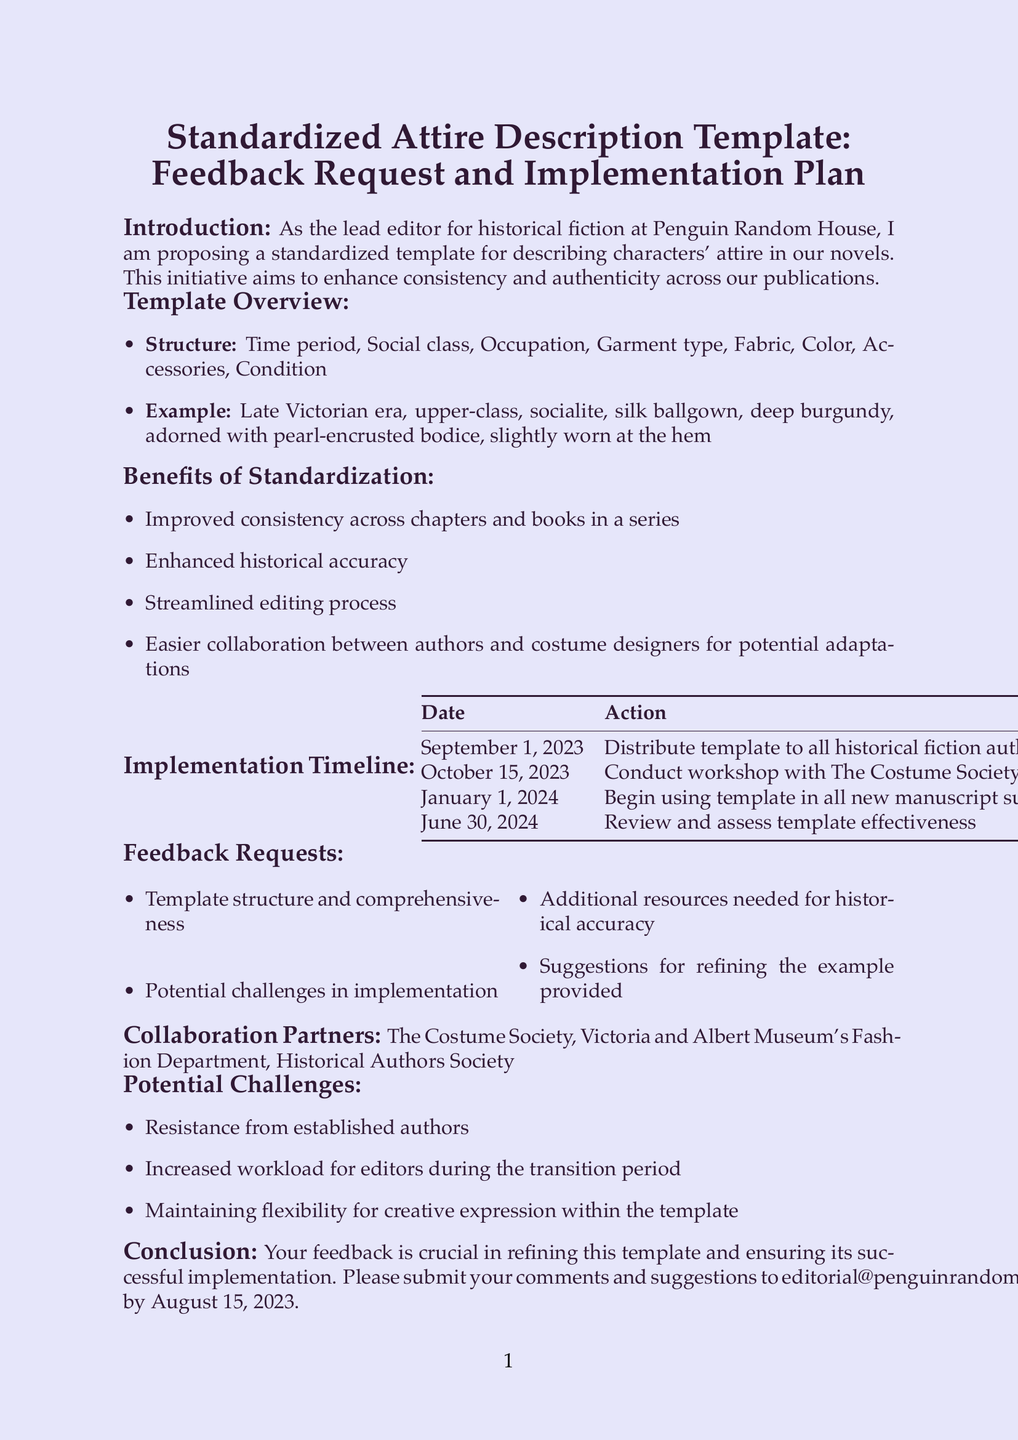what is the title of the memo? The title of the memo is explicitly stated at the top of the document as "Standardized Attire Description Template: Feedback Request and Implementation Plan."
Answer: Standardized Attire Description Template: Feedback Request and Implementation Plan who is proposing the standardized template? The memo states that the lead editor for historical fiction at Penguin Random House is proposing the standardized template.
Answer: lead editor for historical fiction what is the deadline for submitting feedback? The document specifies that feedback should be submitted by August 15, 2023.
Answer: August 15, 2023 how many phases are in the implementation timeline? The implementation timeline consists of four distinct phases as outlined in the document.
Answer: four what is the example provided for the template? An example of the attire description template is provided in the memo to illustrate its usage.
Answer: Late Victorian era, upper-class, socialite, silk ballgown, deep burgundy, adorned with pearl-encrusted bodice, slightly worn at the hem name one collaboration partner mentioned in the document. The memo lists collaboration partners, and one example is The Costume Society.
Answer: The Costume Society what is one potential challenge mentioned in the document? The document highlights several potential challenges, including "Resistance from established authors."
Answer: Resistance from established authors when will the template start being used in new manuscript submissions? The document states that the template will begin being used on January 1, 2024.
Answer: January 1, 2024 how many benefits of standardization are listed? The memo enumerates four distinct benefits of standardization in the benefits section.
Answer: four 